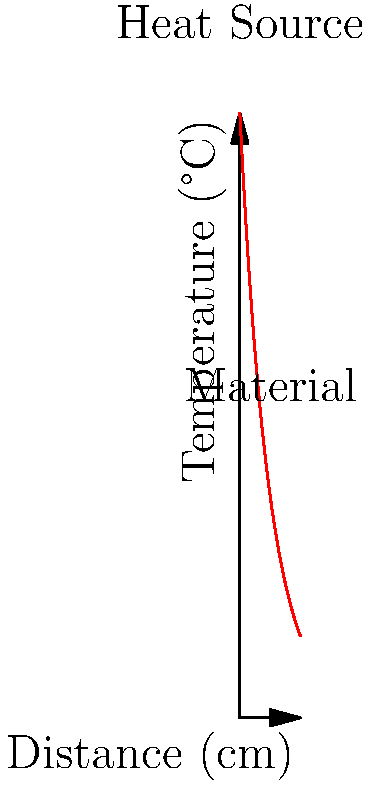As an academic journal editor reviewing a computational physics paper, analyze the graph showing temperature distribution in a simulated heat transfer scenario. What type of heat transfer mechanism does this temperature profile most likely represent, and what physical property of the material can be inferred from the shape of the curve? To answer this question, let's analyze the graph step-by-step:

1. Observe the graph shape: The temperature decreases exponentially from left to right.

2. Identify the heat transfer mechanism:
   - The exponential decay of temperature is characteristic of steady-state heat conduction in a semi-infinite solid.
   - This suggests that heat is being conducted through a material from a constant temperature source.

3. Analyze the mathematical form:
   The curve follows the equation: $$T(x) = T_0 e^{-x/L}$$
   Where $T_0$ is the initial temperature, $x$ is the distance, and $L$ is a characteristic length.

4. Interpret the physical property:
   - The rate of temperature decrease is related to the thermal diffusivity ($\alpha$) of the material.
   - The characteristic length $L$ is proportional to $\sqrt{\alpha}$.
   - A slower decay (larger $L$) implies higher thermal diffusivity, while a faster decay (smaller $L$) implies lower thermal diffusivity.

5. Conclude:
   The heat transfer mechanism is conduction, and the shape of the curve provides information about the material's thermal diffusivity.
Answer: Conduction; thermal diffusivity 